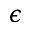Convert formula to latex. <formula><loc_0><loc_0><loc_500><loc_500>\epsilon</formula> 